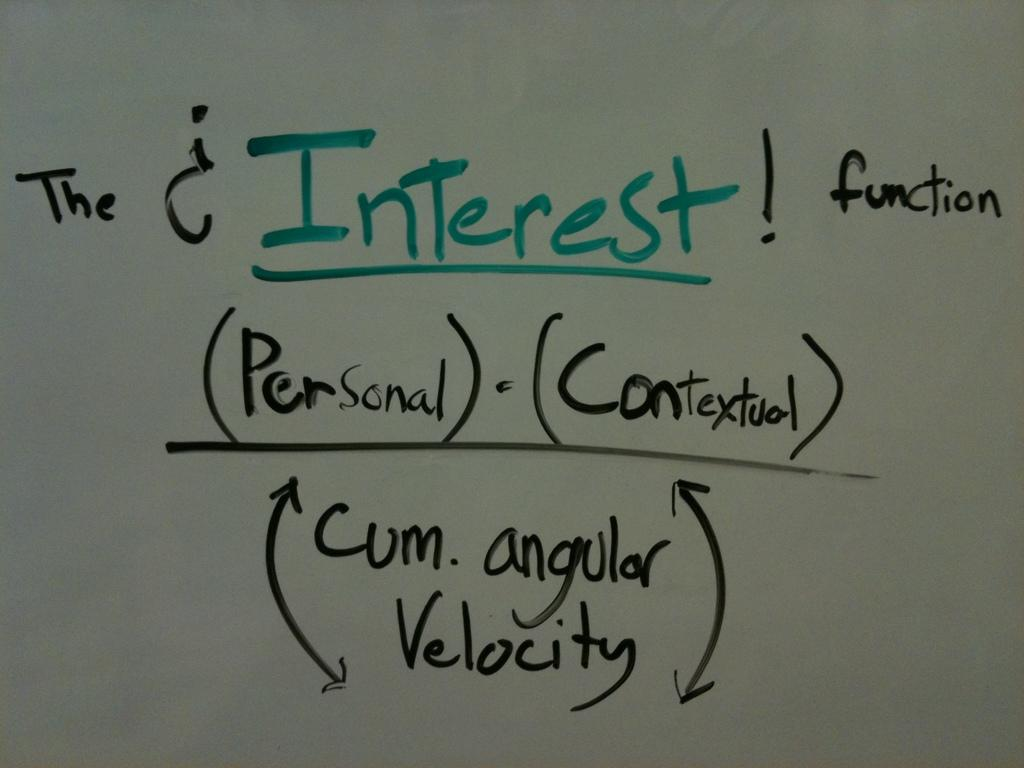<image>
Write a terse but informative summary of the picture. A white board shows the equation for the Interest Function as (Personal) x (Contextual) / Cum.angular velocity. 